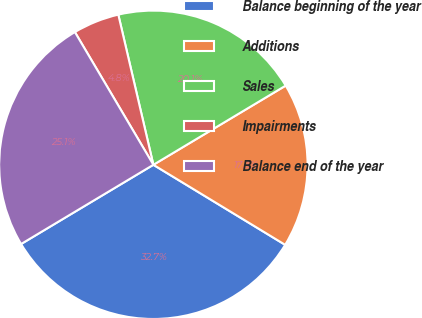<chart> <loc_0><loc_0><loc_500><loc_500><pie_chart><fcel>Balance beginning of the year<fcel>Additions<fcel>Sales<fcel>Impairments<fcel>Balance end of the year<nl><fcel>32.73%<fcel>17.27%<fcel>20.07%<fcel>4.85%<fcel>25.09%<nl></chart> 